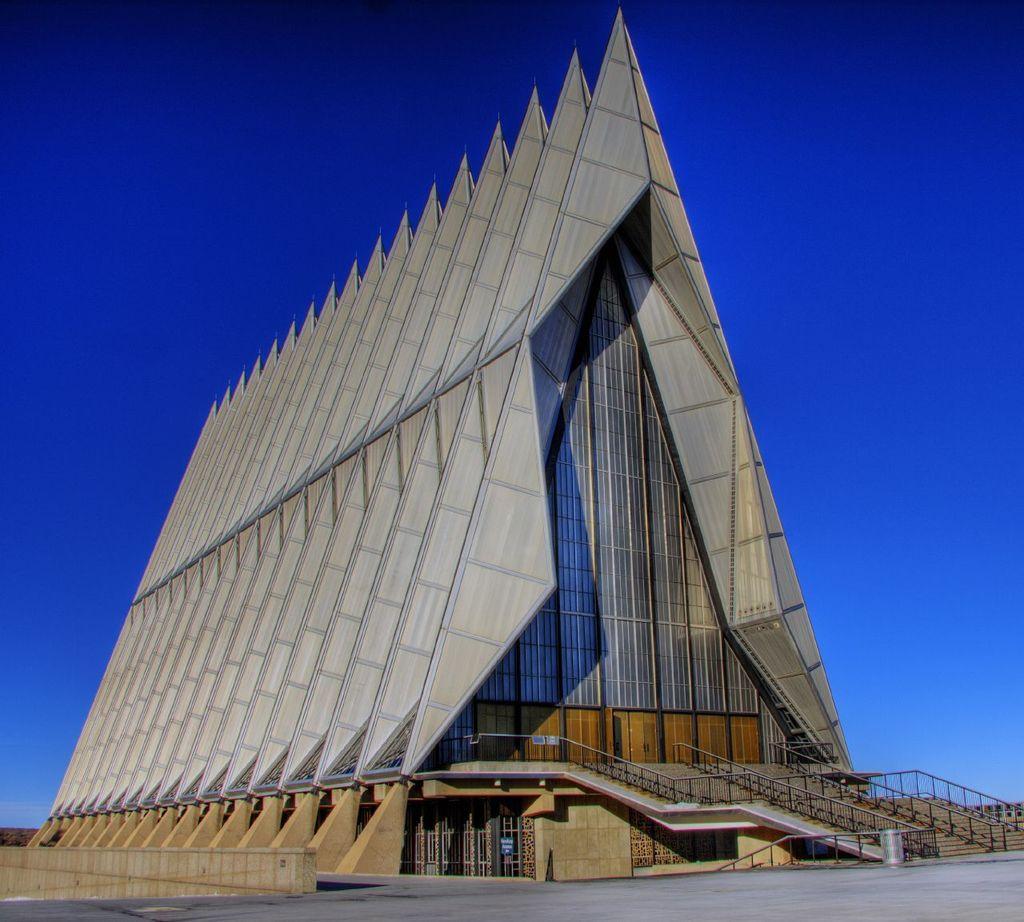Could you give a brief overview of what you see in this image? In the picture we can see some architecture and top of the picture there is clear sky. 